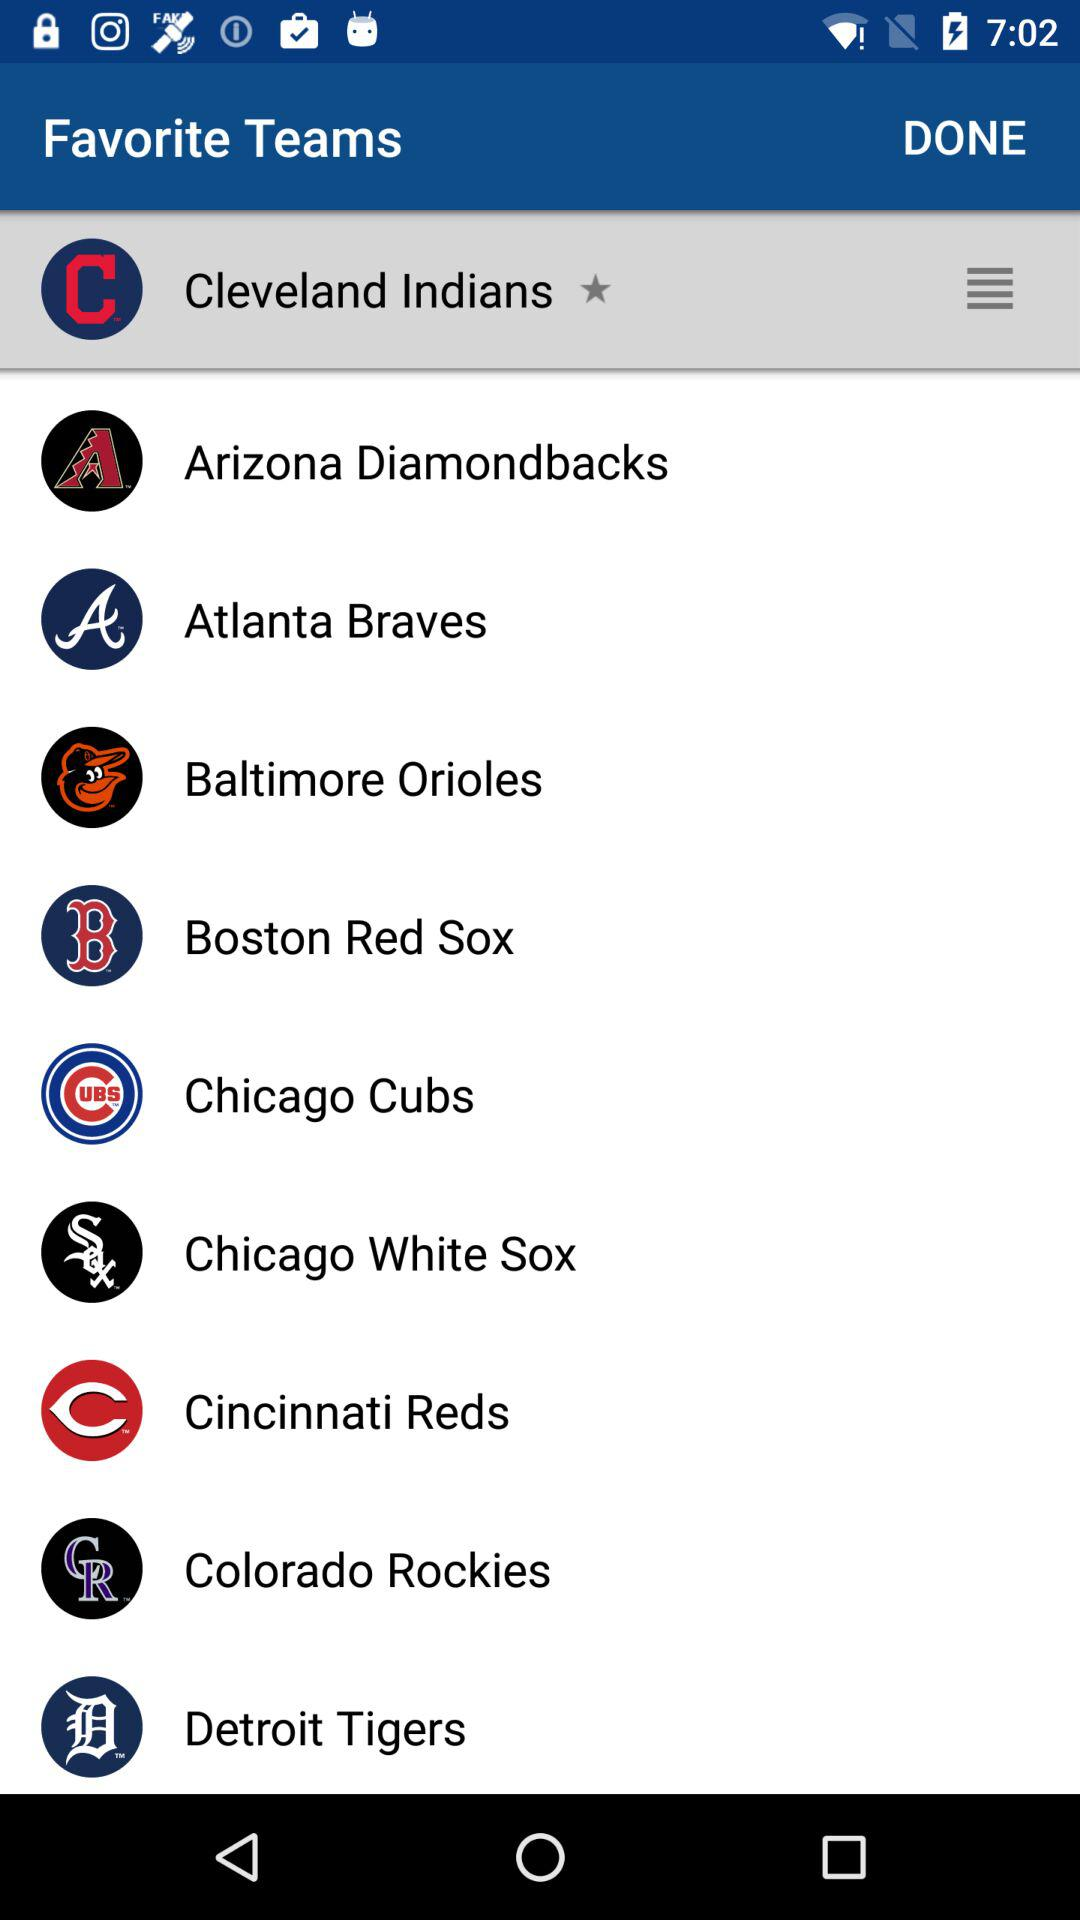How many teams playing in this?
When the provided information is insufficient, respond with <no answer>. <no answer> 